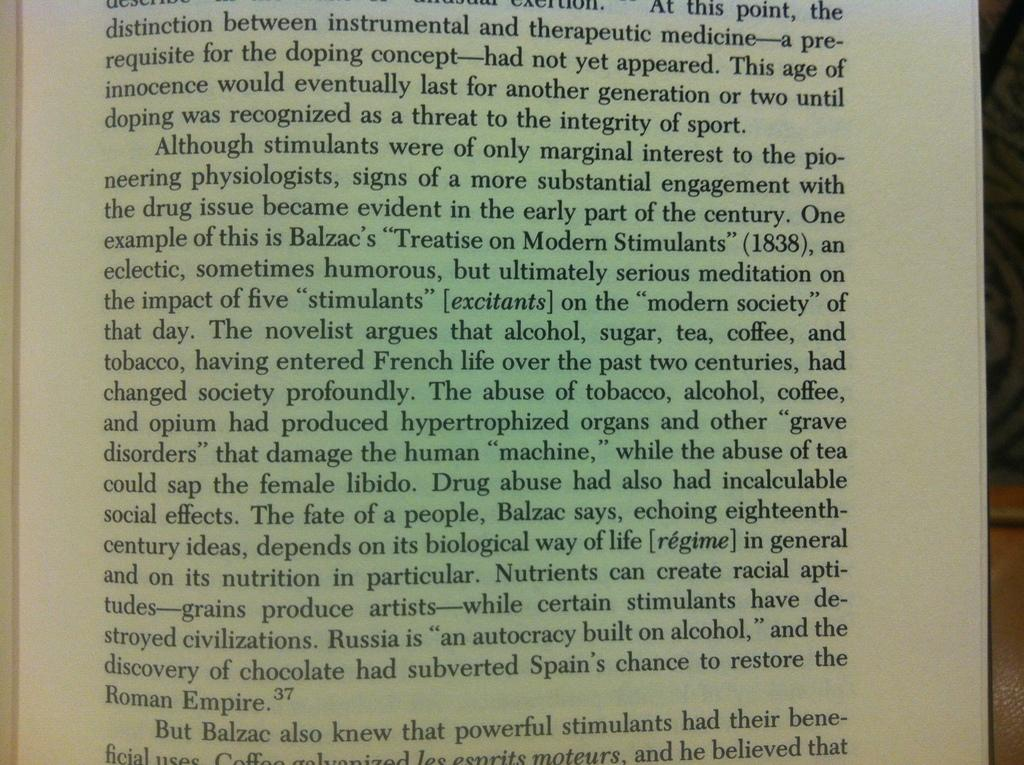Provide a one-sentence caption for the provided image. A book page has information about Balzac and includes footnote number 37. 